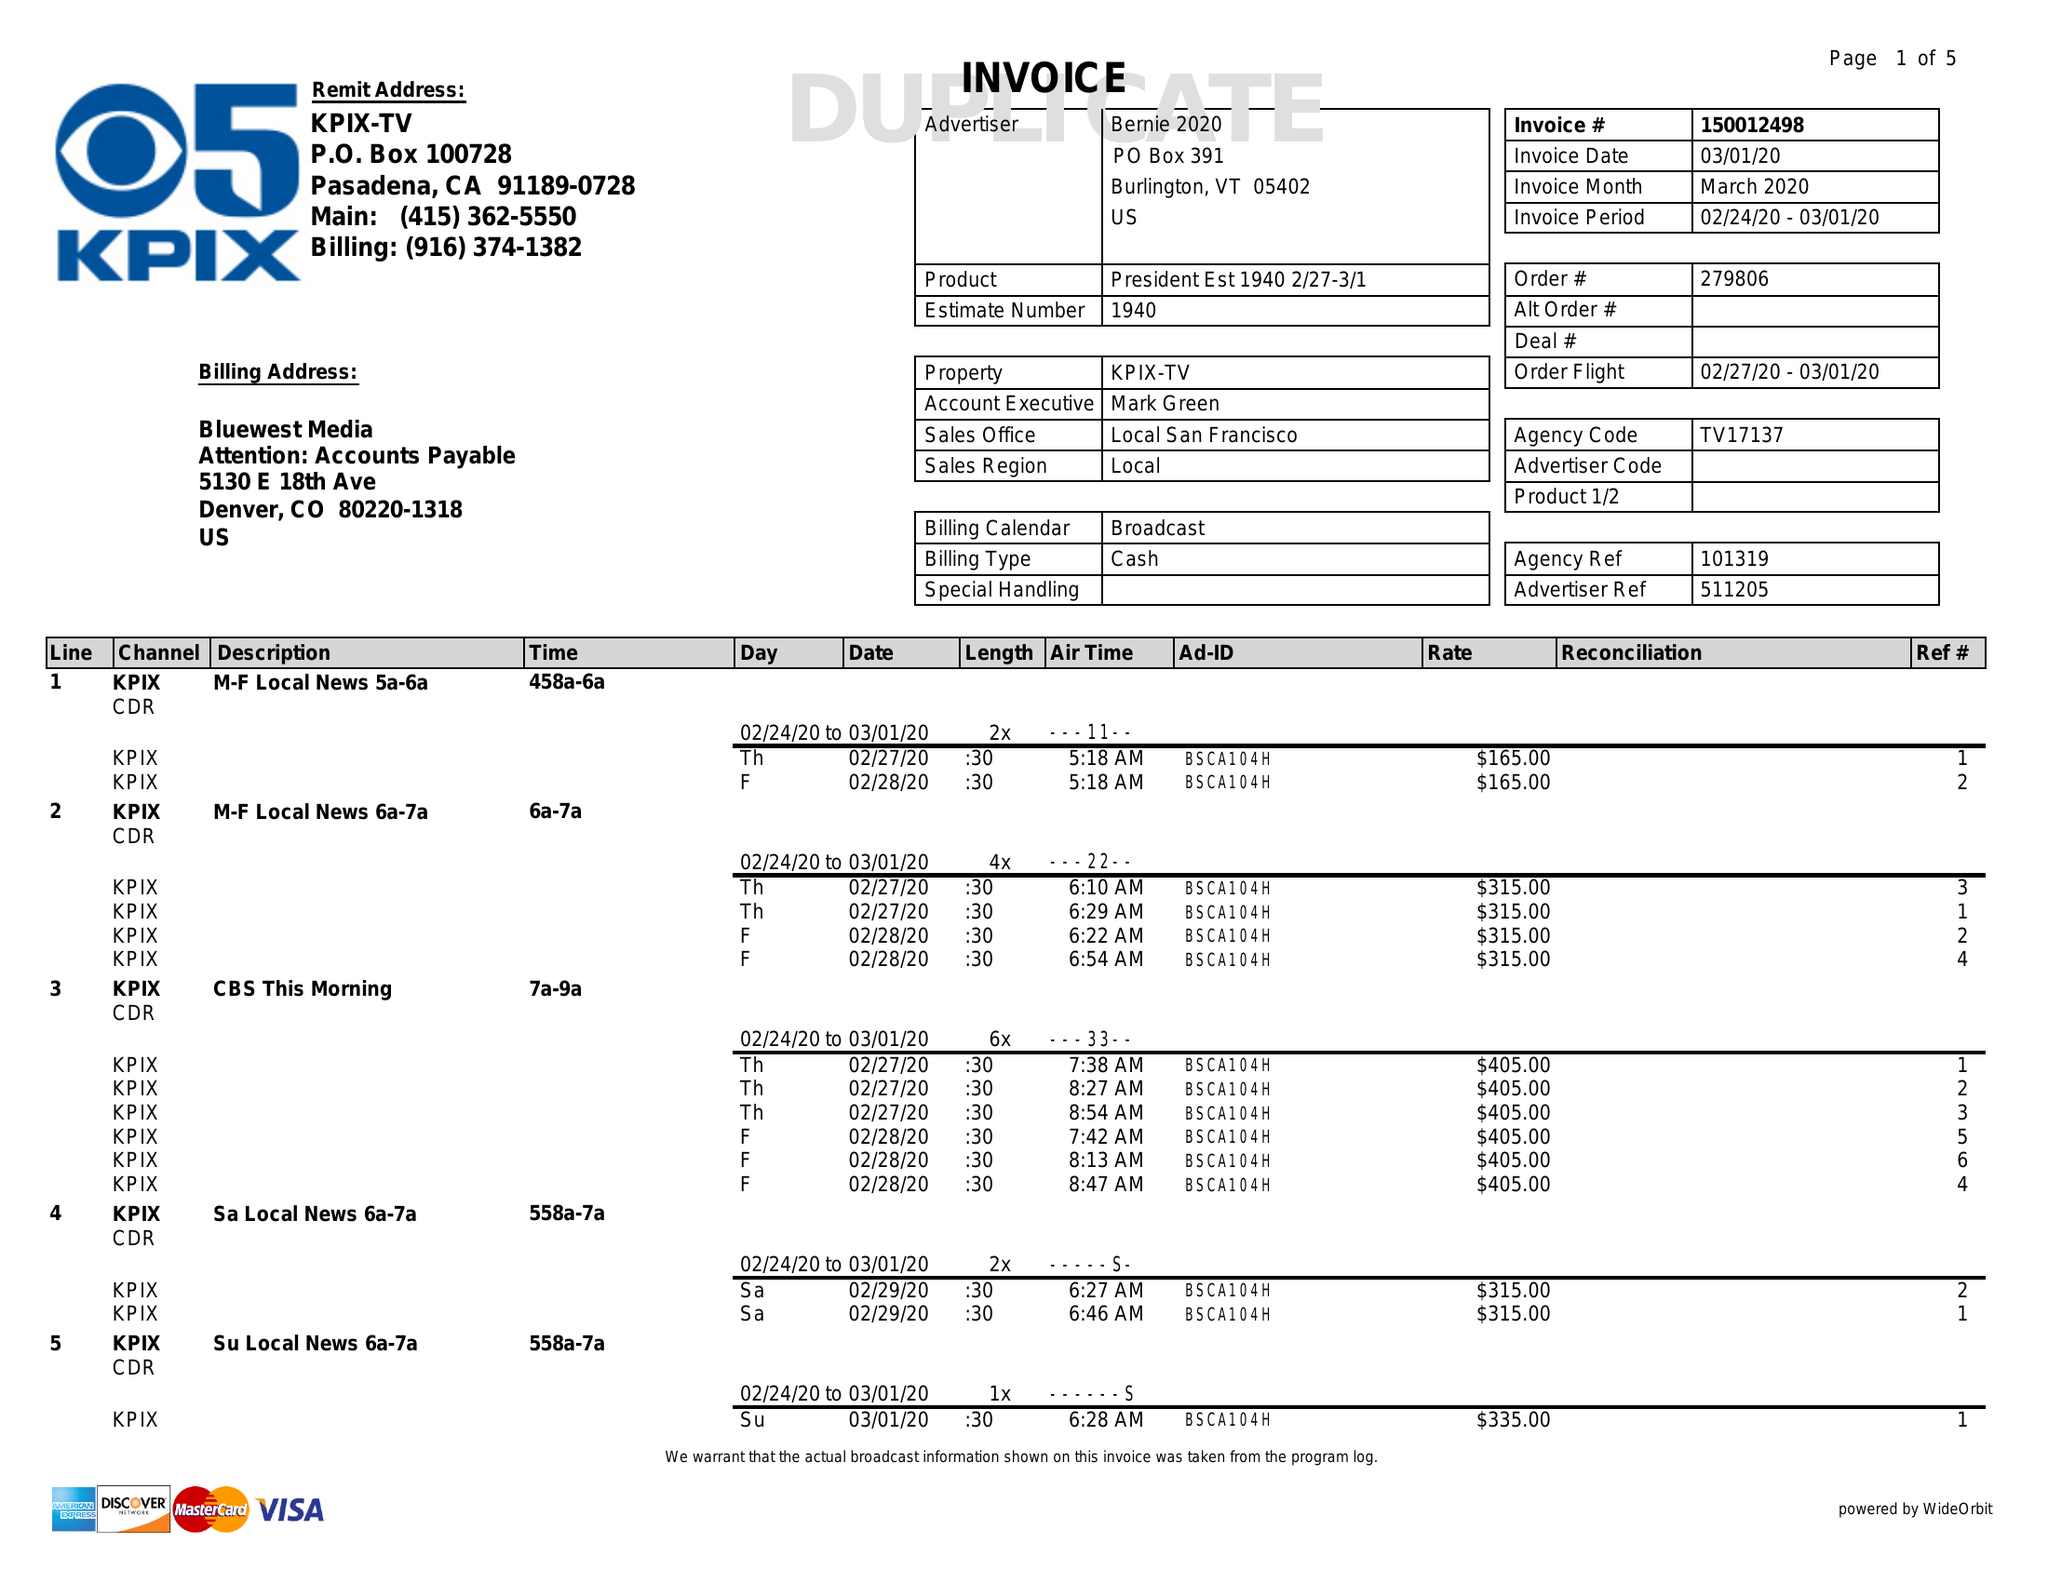What is the value for the gross_amount?
Answer the question using a single word or phrase. 55590.00 